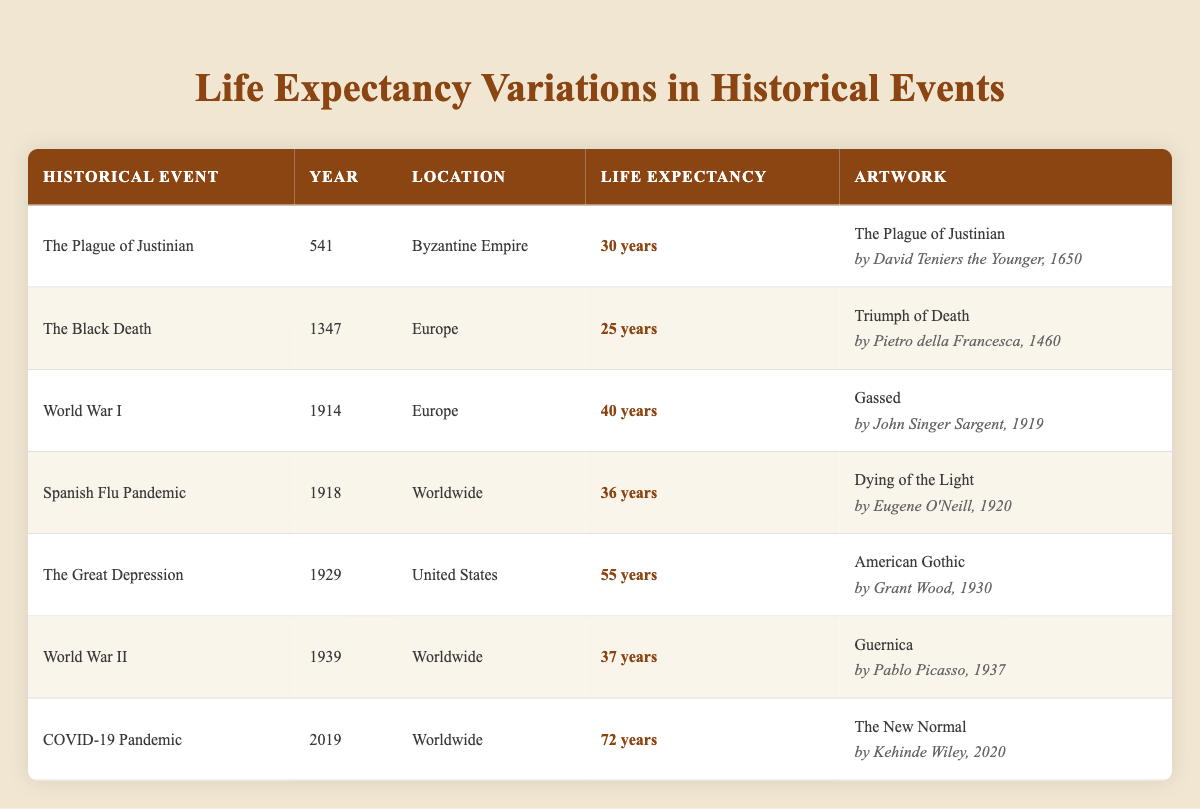What was the life expectancy during the Black Death? The table indicates that the life expectancy during the Black Death in 1347 was 25 years.
Answer: 25 years Which historical event had the highest life expectancy recorded? By examining the table, the highest life expectancy recorded is 72 years during the COVID-19 Pandemic in 2019.
Answer: 72 years Is the artwork "Guernica" associated with an event that had a life expectancy below 40 years? The table shows that the life expectancy during World War II, associated with "Guernica," was 37 years, which is below 40.
Answer: Yes What is the difference in life expectancy between the Plague of Justinian and World War I? The table provides a life expectancy of 30 years for the Plague of Justinian and 40 years for World War I. The difference is 40 - 30 = 10 years.
Answer: 10 years What average life expectancy can be calculated from the events of the Great Depression, World War II, and the COVID-19 Pandemic? The life expectancies for these events are 55 years, 37 years, and 72 years, respectively. The average is (55 + 37 + 72) / 3 = 54.67 years.
Answer: 54.67 years How many years did the life expectancy decrease from the Black Death to the Plague of Justinian? The life expectancy for the Black Death was 25 years, while for the Plague of Justinian, it was 30 years. The decrease is 30 - 25 = 5 years.
Answer: 5 years Did the Spanish Flu Pandemic have a life expectancy greater than that of World War I? The Spanish Flu Pandemic's life expectancy was 36 years, and World War I's was 40 years; therefore, the Spanish Flu Pandemic did not have a greater life expectancy.
Answer: No Which event saw an increase in life expectancy compared to the previous historical event? The life expectancy during the COVID-19 Pandemic (72 years) increased from the life expectancy during World War II (37 years), indicating an upward change.
Answer: Yes What was the year of the event with the lowest life expectancy, and what was that value? The table shows that the event with the lowest life expectancy was the Black Death in 1347, with a life expectancy of 25 years.
Answer: 1347, 25 years 